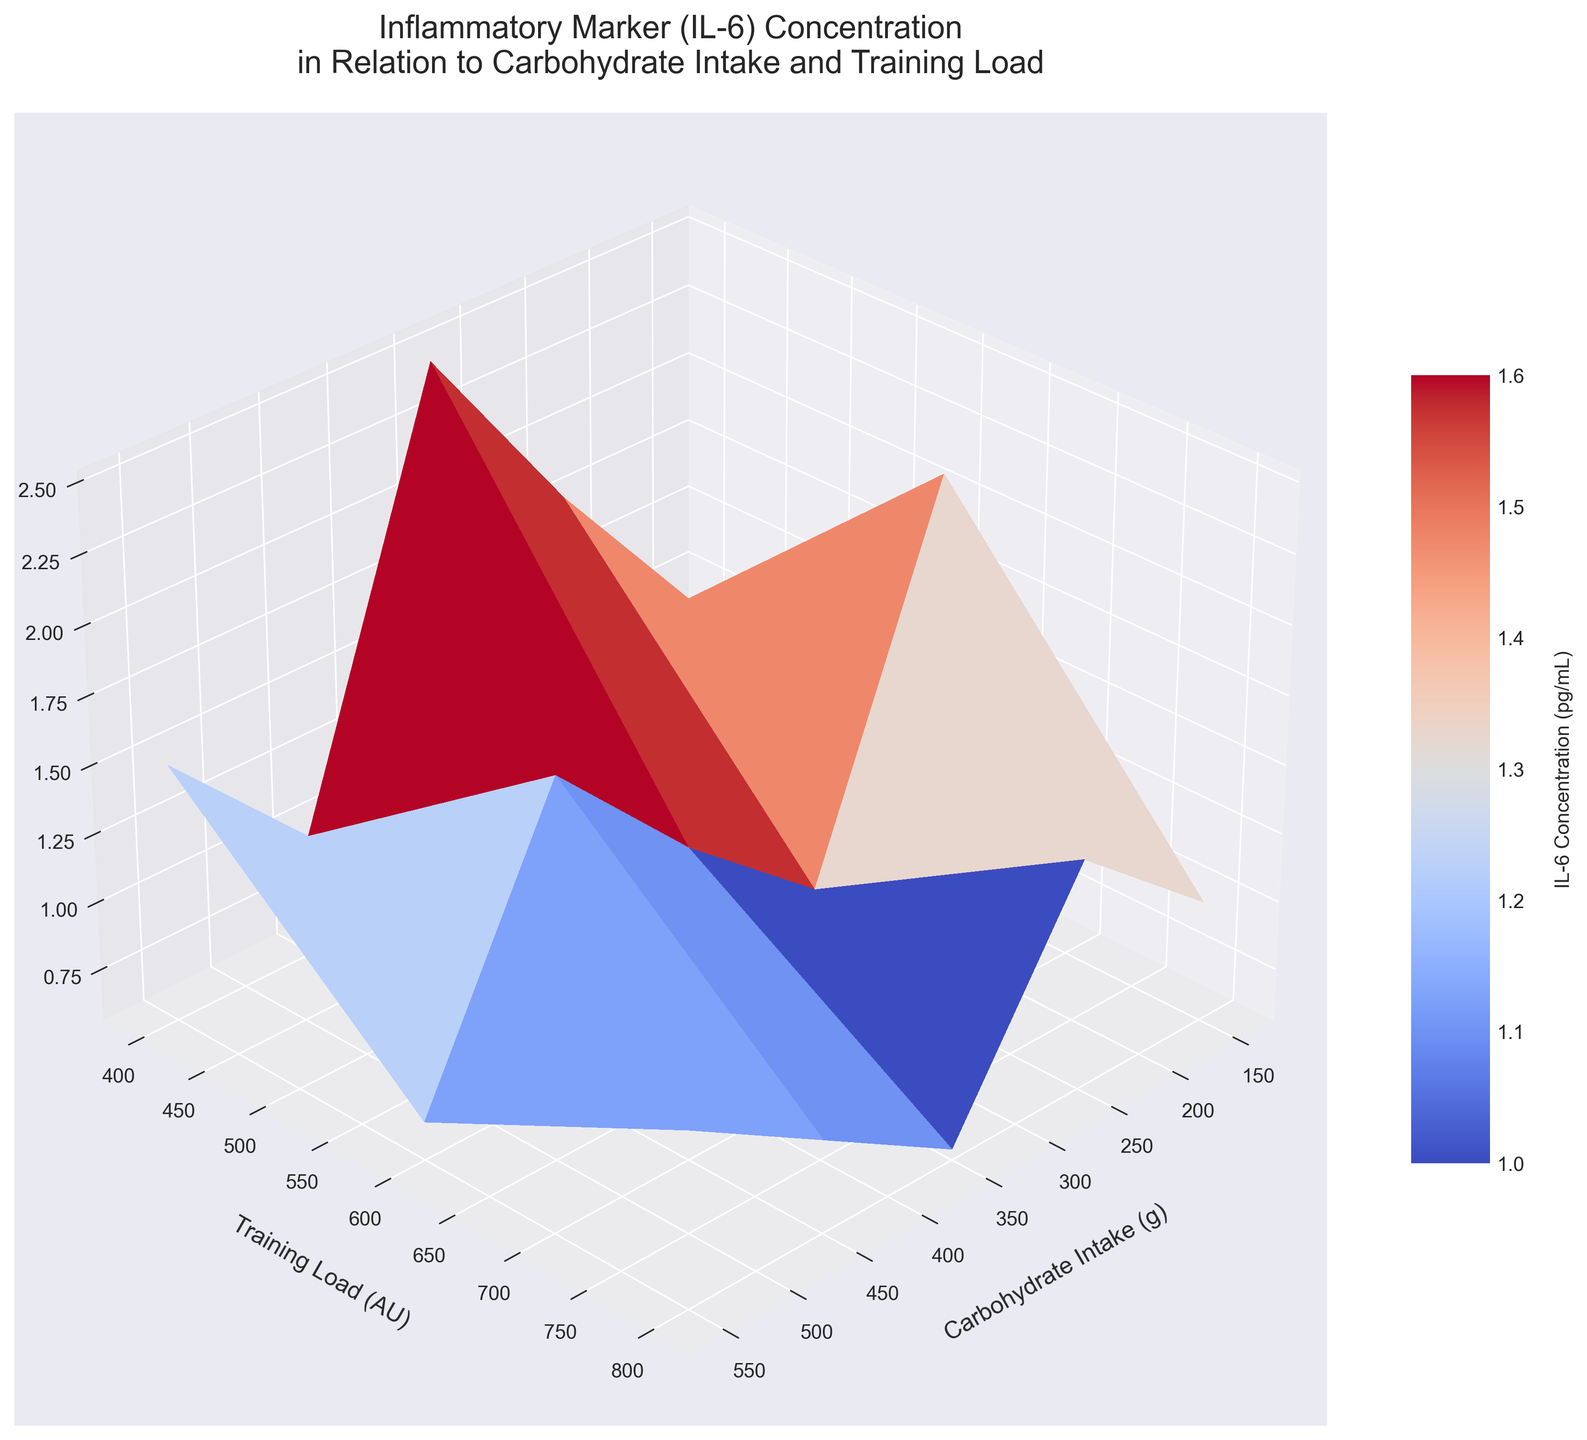What's the title of the plot? The title of the plot is usually located at the top and summarizes the overall theme being represented. Here, it reads "Inflammatory Marker (IL-6) Concentration in Relation to Carbohydrate Intake and Training Load."
Answer: Inflammatory Marker (IL-6) Concentration in Relation to Carbohydrate Intake and Training Load What are the axes labels? The x-axis, y-axis, and z-axis labels are typically used to specify what each axis represents. Here, the x-axis is labeled 'Carbohydrate Intake (g)', the y-axis is labeled 'Training Load (AU)', and the z-axis is labeled 'IL-6 (pg/mL)'.
Answer: Carbohydrate Intake (g), Training Load (AU), IL-6 (pg/mL) How does the IL-6 concentration change with increasing carbohydrate intake at a constant training load of 400 AU? To determine this, observe the z-axis values at a y-axis value of 400 AU across different x-axis values (Carbohydrate Intake). As carbohydrate intake increases from 150g to 550g, IL-6 concentration decreases from around 1.2 pg/mL to 0.6 pg/mL.
Answer: Decreases from 1.2 pg/mL to 0.6 pg/mL What is the IL-6 concentration at the lowest carbohydrate intake and highest training load? Find the z-axis value where the x-axis value is at its minimum (150g) and the y-axis value is at its maximum (800 AU). The IL-6 concentration at this point is 2.5 pg/mL.
Answer: 2.5 pg/mL Which combination of carbohydrate intake and training load results in the lowest IL-6 concentration? By looking at the plot, identify the point where the z-axis value is at its minimum. The lowest IL-6 concentration occurs at the highest carbohydrate intake (550g) and the lowest training load (400 AU).
Answer: 550g carbohydrate intake and 400 AU training load How does the IL-6 concentration compare between a carbohydrate intake of 250g and 350g at a training load of 600 AU? Compare the z-axis values for these intake levels at a y-axis value of 600 AU. At 250g, the IL-6 concentration is about 1.5 pg/mL, and at 350g, it is about 1.2 pg/mL.
Answer: Higher at 250g (1.5 pg/mL) than at 350g (1.2 pg/mL) At a training load of 800 AU, which shows a greater reduction in IL-6 concentration: increasing carbohydrate intake from 150g to 250g, or from 450g to 550g? Find the decrease in IL-6 concentration by looking at the z-axis values. 150g to 250g shows a reduction from 2.5 to 2.1 (a reduction of 0.4), and 450g to 550g shows a reduction from 1.4 to 1.2 (a reduction of 0.2). Therefore, the reduction is greater from 150g to 250g.
Answer: From 150g to 250g (0.4 pg/mL reduction) What color range is used in the plot to represent IL-6 concentrations? The color bar next to the plot indicates the color scheme. It uses a gradient that transitions from cooler colors (blue) to warmer colors (red).
Answer: Cool to warm (blue to red) How would you describe the overall trend of IL-6 concentration in relation to both carbohydrate intake and training load? IL-6 concentration tends to increase with higher training loads and decrease with higher carbohydrate intakes, as depicted by the gradient and surface trends in the 3D plot.
Answer: Increases with higher training load and decreases with higher carbohydrate intake Is there a specific viewpoint from which this 3D plot is visualized? The viewing angle specified for the 3D plot is elevated at 30 degrees and rotated azimuthally at 45 degrees to enhance the visualization of the surface data.
Answer: 30 degrees elevation and 45 degrees azimuth 